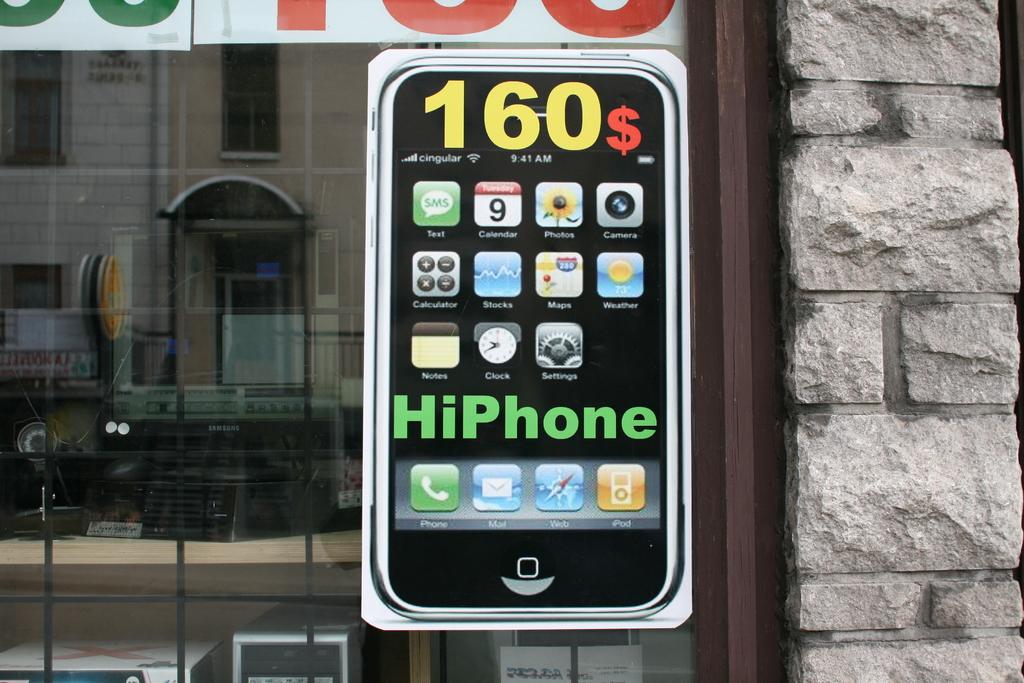What brand is the cell phone?
Give a very brief answer. Hiphone. How much is the phone?
Your response must be concise. 160. 